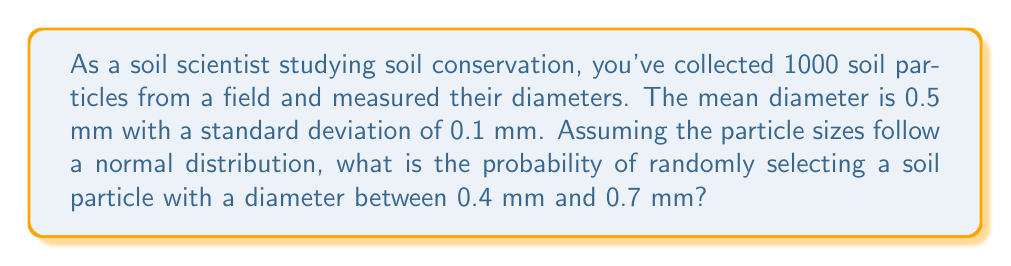Solve this math problem. To solve this problem, we'll use the properties of the normal distribution and the z-score formula.

Step 1: Identify the given information
- Mean (μ) = 0.5 mm
- Standard deviation (σ) = 0.1 mm
- Lower bound (x₁) = 0.4 mm
- Upper bound (x₂) = 0.7 mm

Step 2: Calculate the z-scores for both bounds
z-score formula: $z = \frac{x - \mu}{\sigma}$

For x₁ = 0.4 mm:
$z_1 = \frac{0.4 - 0.5}{0.1} = -1$

For x₂ = 0.7 mm:
$z_2 = \frac{0.7 - 0.5}{0.1} = 2$

Step 3: Use a standard normal distribution table or calculator to find the area under the curve between z₁ and z₂

Area = P(z₂) - P(z₁)
     = P(2) - P(-1)
     ≈ 0.9772 - 0.1587
     ≈ 0.8185

Step 4: Convert the result to a percentage
0.8185 × 100% ≈ 81.85%

Therefore, the probability of randomly selecting a soil particle with a diameter between 0.4 mm and 0.7 mm is approximately 81.85%.
Answer: 81.85% 